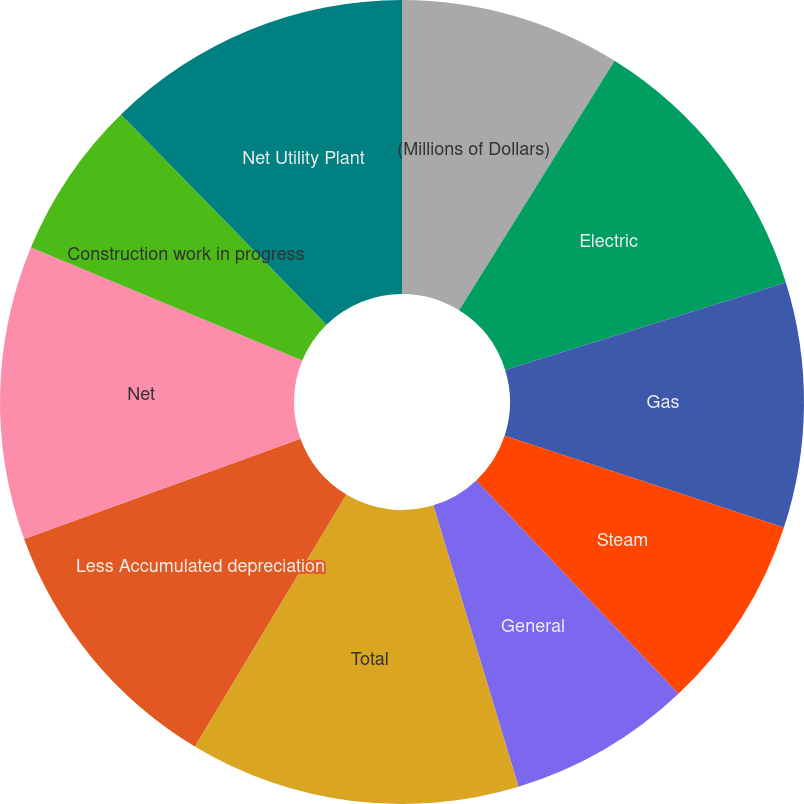<chart> <loc_0><loc_0><loc_500><loc_500><pie_chart><fcel>(Millions of Dollars)<fcel>Electric<fcel>Gas<fcel>Steam<fcel>General<fcel>Total<fcel>Less Accumulated depreciation<fcel>Net<fcel>Construction work in progress<fcel>Net Utility Plant<nl><fcel>8.87%<fcel>11.33%<fcel>9.85%<fcel>7.88%<fcel>7.39%<fcel>13.3%<fcel>10.84%<fcel>11.82%<fcel>6.4%<fcel>12.32%<nl></chart> 